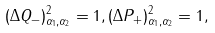<formula> <loc_0><loc_0><loc_500><loc_500>( \Delta Q _ { - } ) ^ { 2 } _ { \alpha _ { 1 } , \alpha _ { 2 } } = 1 , ( \Delta P _ { + } ) ^ { 2 } _ { \alpha _ { 1 } , \alpha _ { 2 } } = 1 ,</formula> 